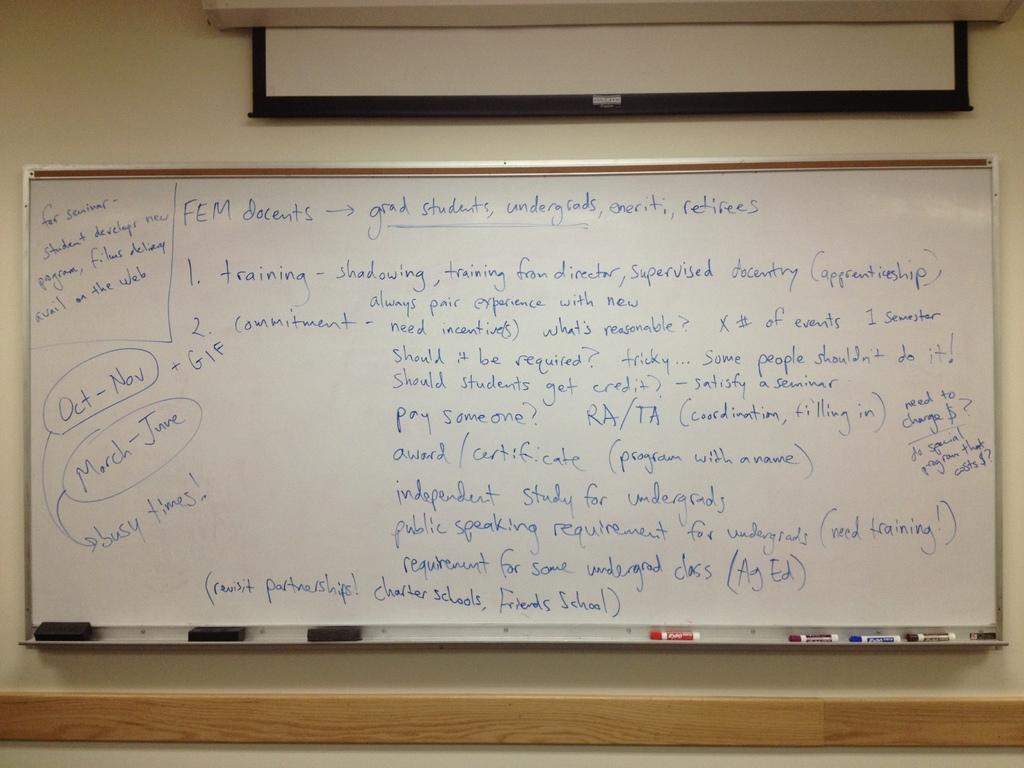<image>
Share a concise interpretation of the image provided. A side note on the whiteboard states Oct through Nov and March through June will be busy times. 